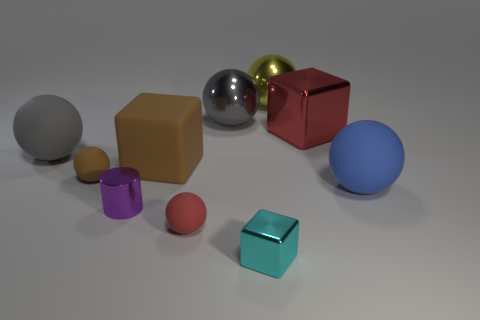Subtract 1 balls. How many balls are left? 5 Subtract all blue spheres. How many spheres are left? 5 Subtract all small red balls. How many balls are left? 5 Subtract all yellow balls. Subtract all purple cubes. How many balls are left? 5 Subtract all cylinders. How many objects are left? 9 Add 2 gray metallic spheres. How many gray metallic spheres are left? 3 Add 5 large cyan metal cylinders. How many large cyan metal cylinders exist? 5 Subtract 1 brown balls. How many objects are left? 9 Subtract all red rubber things. Subtract all large rubber things. How many objects are left? 6 